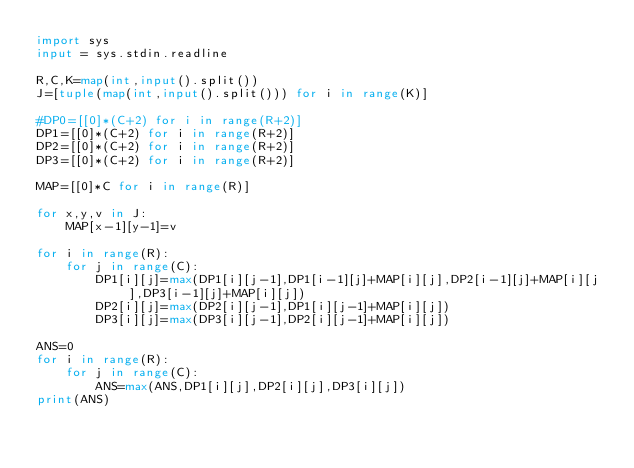<code> <loc_0><loc_0><loc_500><loc_500><_Python_>import sys
input = sys.stdin.readline

R,C,K=map(int,input().split())
J=[tuple(map(int,input().split())) for i in range(K)]

#DP0=[[0]*(C+2) for i in range(R+2)]
DP1=[[0]*(C+2) for i in range(R+2)]
DP2=[[0]*(C+2) for i in range(R+2)]
DP3=[[0]*(C+2) for i in range(R+2)]

MAP=[[0]*C for i in range(R)]

for x,y,v in J:
    MAP[x-1][y-1]=v

for i in range(R):
    for j in range(C):
        DP1[i][j]=max(DP1[i][j-1],DP1[i-1][j]+MAP[i][j],DP2[i-1][j]+MAP[i][j],DP3[i-1][j]+MAP[i][j])
        DP2[i][j]=max(DP2[i][j-1],DP1[i][j-1]+MAP[i][j])
        DP3[i][j]=max(DP3[i][j-1],DP2[i][j-1]+MAP[i][j])

ANS=0
for i in range(R):
    for j in range(C):
        ANS=max(ANS,DP1[i][j],DP2[i][j],DP3[i][j])
print(ANS)

</code> 